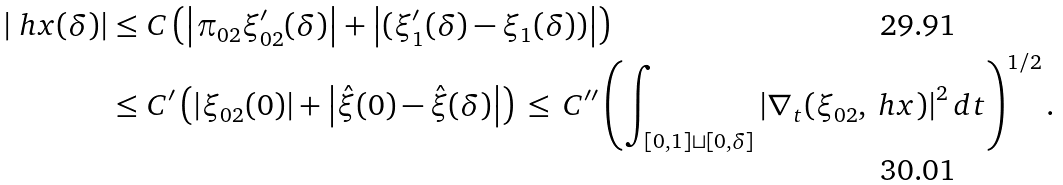<formula> <loc_0><loc_0><loc_500><loc_500>\left | \ h x ( \delta ) \right | & \leq C \left ( \left | \pi _ { 0 2 } \xi ^ { \prime } _ { 0 2 } ( \delta ) \right | + \left | ( \xi _ { 1 } ^ { \prime } ( \delta ) - \xi _ { 1 } ( \delta ) ) \right | \right ) \\ & \leq C ^ { \prime } \left ( \left | \xi _ { 0 2 } ( 0 ) \right | + \left | \hat { \xi } ( 0 ) - \hat { \xi } ( \delta ) \right | \right ) \, \leq \, C ^ { \prime \prime } \left ( \int _ { [ 0 , 1 ] \sqcup [ 0 , \delta ] } \left | \nabla _ { t } ( \xi _ { 0 2 } , \ h x ) \right | ^ { 2 } d t \right ) ^ { 1 / 2 } .</formula> 